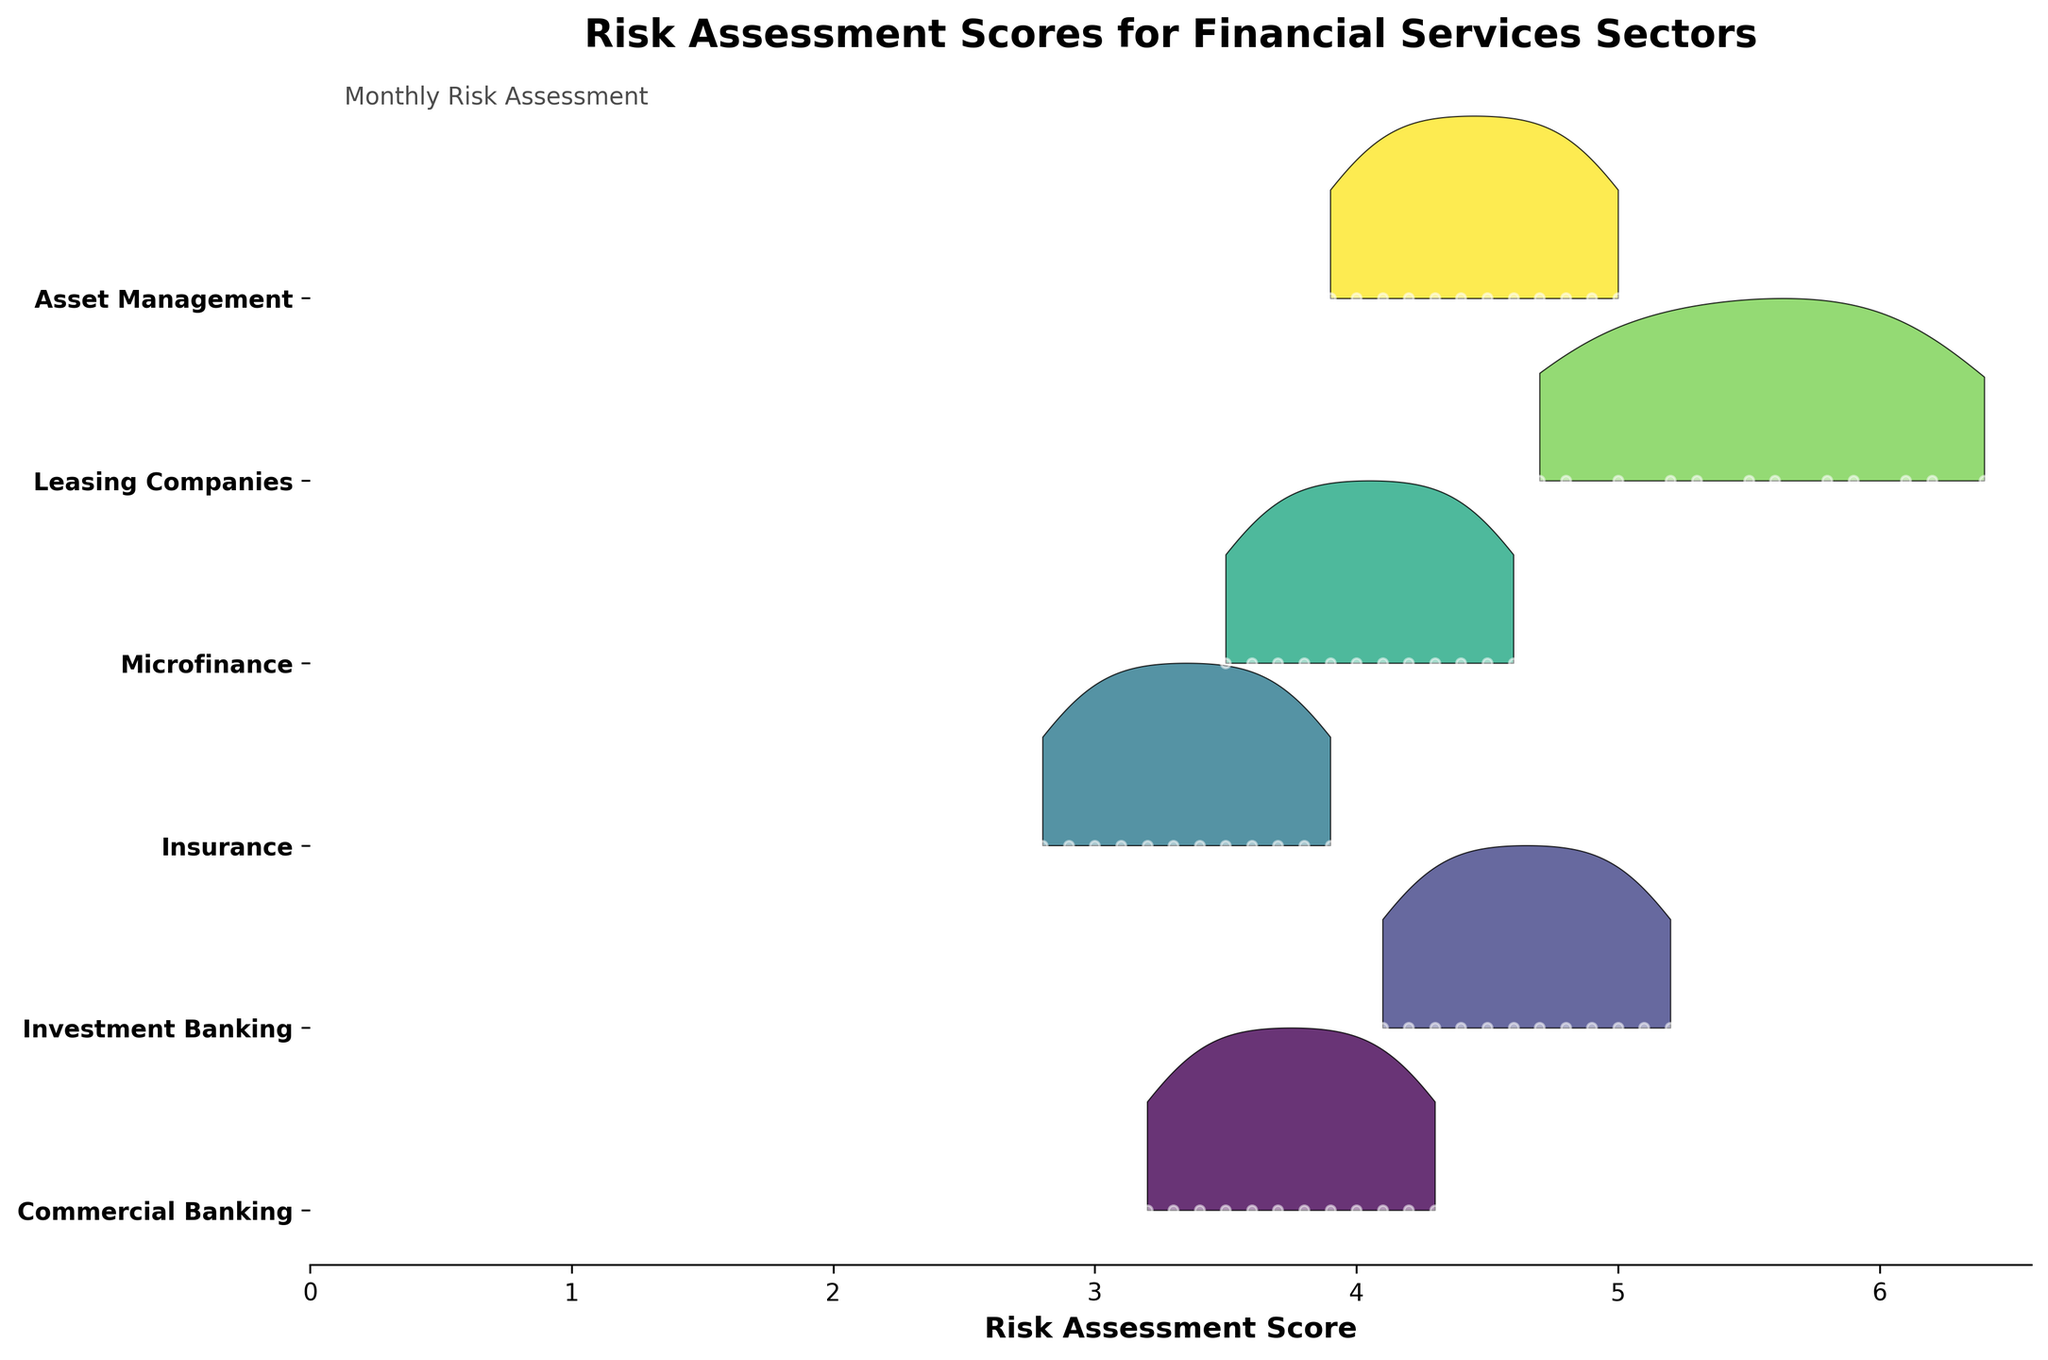What is the title of the plot? The title is usually displayed prominently at the top of the plot. In this case, the title of the plot is "Risk Assessment Scores for Financial Services Sectors."
Answer: Risk Assessment Scores for Financial Services Sectors What are the financial services sectors displayed on the y-axis? The y-axis labels are visible, showing the different sectors analyzed. They are Commercial Banking, Investment Banking, Insurance, Microfinance, Leasing Companies, and Asset Management.
Answer: Commercial Banking, Investment Banking, Insurance, Microfinance, Leasing Companies, Asset Management Which month shows the highest risk assessment score for Leasing Companies? We need to look at the plot line for Leasing Companies and identify the month when it reaches its peak. According to the data, this happens in December.
Answer: December Which sector has the most consistently increasing risk assessment scores over the months? By examining each sector's trend line and observing which line consistently moves upwards month by month, we see that Leasing Companies always increase without any drop.
Answer: Leasing Companies How does the risk assessment score of Commercial Banking change from January to December? The plot details the monthly scores for Commercial Banking. It shows a month-by-month increase from 3.2 in January to 4.3 in December, seeing an upward trend throughout the year.
Answer: Increases from 3.2 to 4.3 Compare the average risk assessment scores of Commercial Banking and Investment Banking throughout the year. To find the average score, sum each month's score for both sectors and then divide by 12. For Commercial Banking: (3.2+3.3+3.4+3.5+3.6+3.7+3.8+3.9+4.0+4.1+4.2+4.3)/12 = 3.65. For Investment Banking: (4.1+4.3+4.2+4.4+4.5+4.6+4.7+4.8+4.9+5.0+5.1+5.2)/12 = 4.6.
Answer: Commercial Banking: 3.65, Investment Banking: 4.6 Between which two consecutive months did Microfinance experience the greatest increase in risk assessment score? By observing the trend line of Microfinance, the largest jump is between January and February, where the score increased from 3.5 to 3.6.
Answer: January to February Which sector displays the most fluctuation in their risk assessment scores? Fluctuation can be inferred by the variation in the density and spread of the plot lines. However, in this case, all the sectors show a steadily increasing trend with no decrease, so no sector shows fluctuation or variance.
Answer: None In which month does Asset Management have a risk assessment score of 4.6? The line for Asset Management should be followed until it reaches 4.6. According to the plot, this occurs in August.
Answer: August 